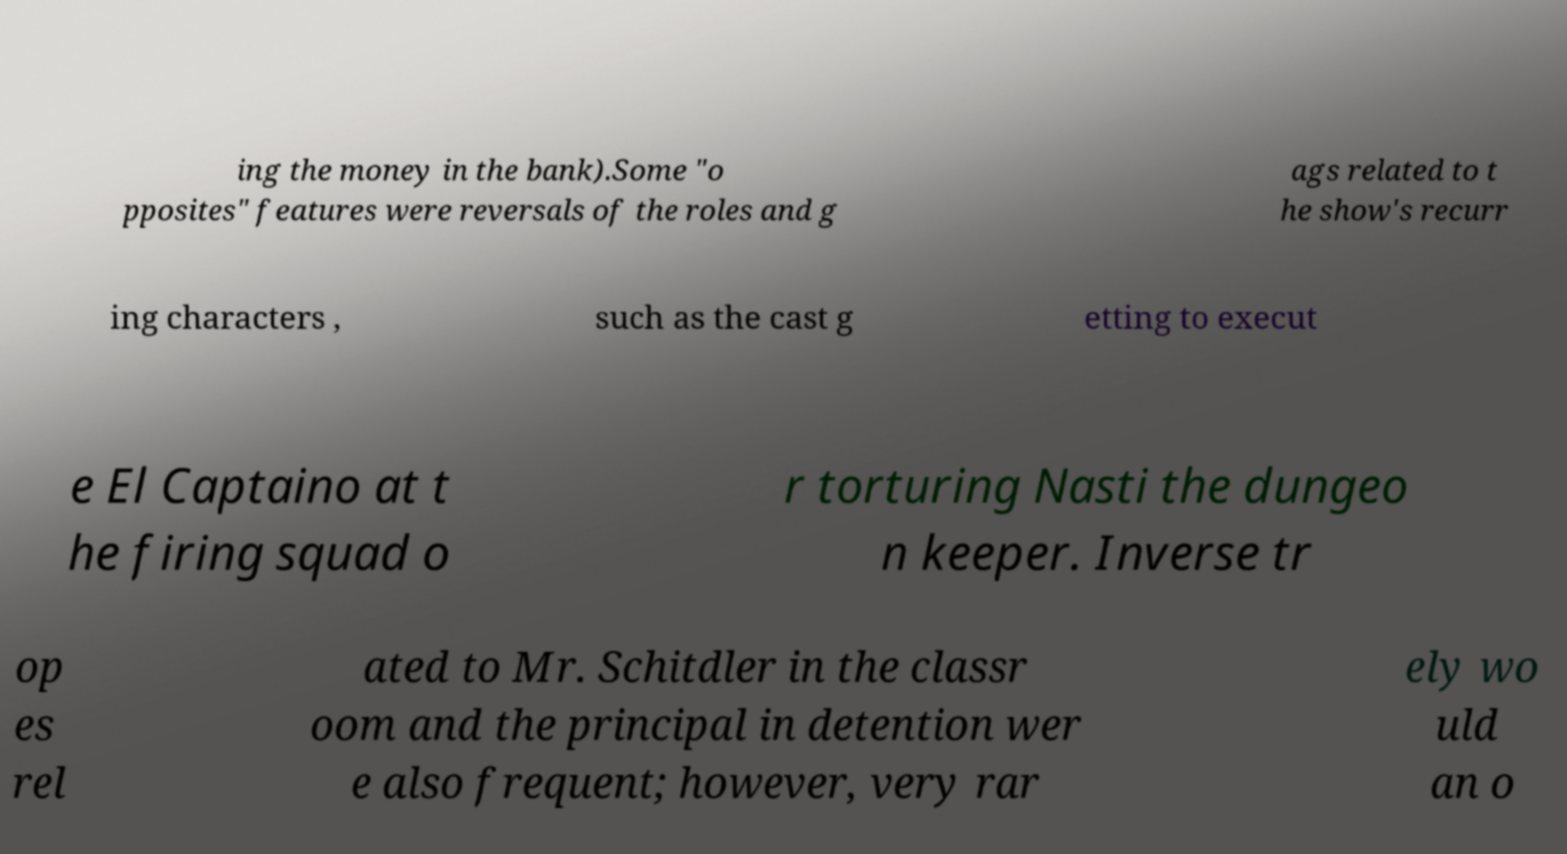For documentation purposes, I need the text within this image transcribed. Could you provide that? ing the money in the bank).Some "o pposites" features were reversals of the roles and g ags related to t he show's recurr ing characters , such as the cast g etting to execut e El Captaino at t he firing squad o r torturing Nasti the dungeo n keeper. Inverse tr op es rel ated to Mr. Schitdler in the classr oom and the principal in detention wer e also frequent; however, very rar ely wo uld an o 